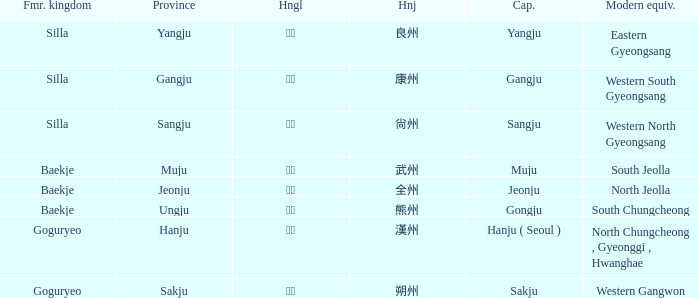What is the hangul symbol for the hanja 良州? 양주. Would you mind parsing the complete table? {'header': ['Fmr. kingdom', 'Province', 'Hngl', 'Hnj', 'Cap.', 'Modern equiv.'], 'rows': [['Silla', 'Yangju', '양주', '良州', 'Yangju', 'Eastern Gyeongsang'], ['Silla', 'Gangju', '강주', '康州', 'Gangju', 'Western South Gyeongsang'], ['Silla', 'Sangju', '상주', '尙州', 'Sangju', 'Western North Gyeongsang'], ['Baekje', 'Muju', '무주', '武州', 'Muju', 'South Jeolla'], ['Baekje', 'Jeonju', '전주', '全州', 'Jeonju', 'North Jeolla'], ['Baekje', 'Ungju', '웅주', '熊州', 'Gongju', 'South Chungcheong'], ['Goguryeo', 'Hanju', '한주', '漢州', 'Hanju ( Seoul )', 'North Chungcheong , Gyeonggi , Hwanghae'], ['Goguryeo', 'Sakju', '삭주', '朔州', 'Sakju', 'Western Gangwon']]} 